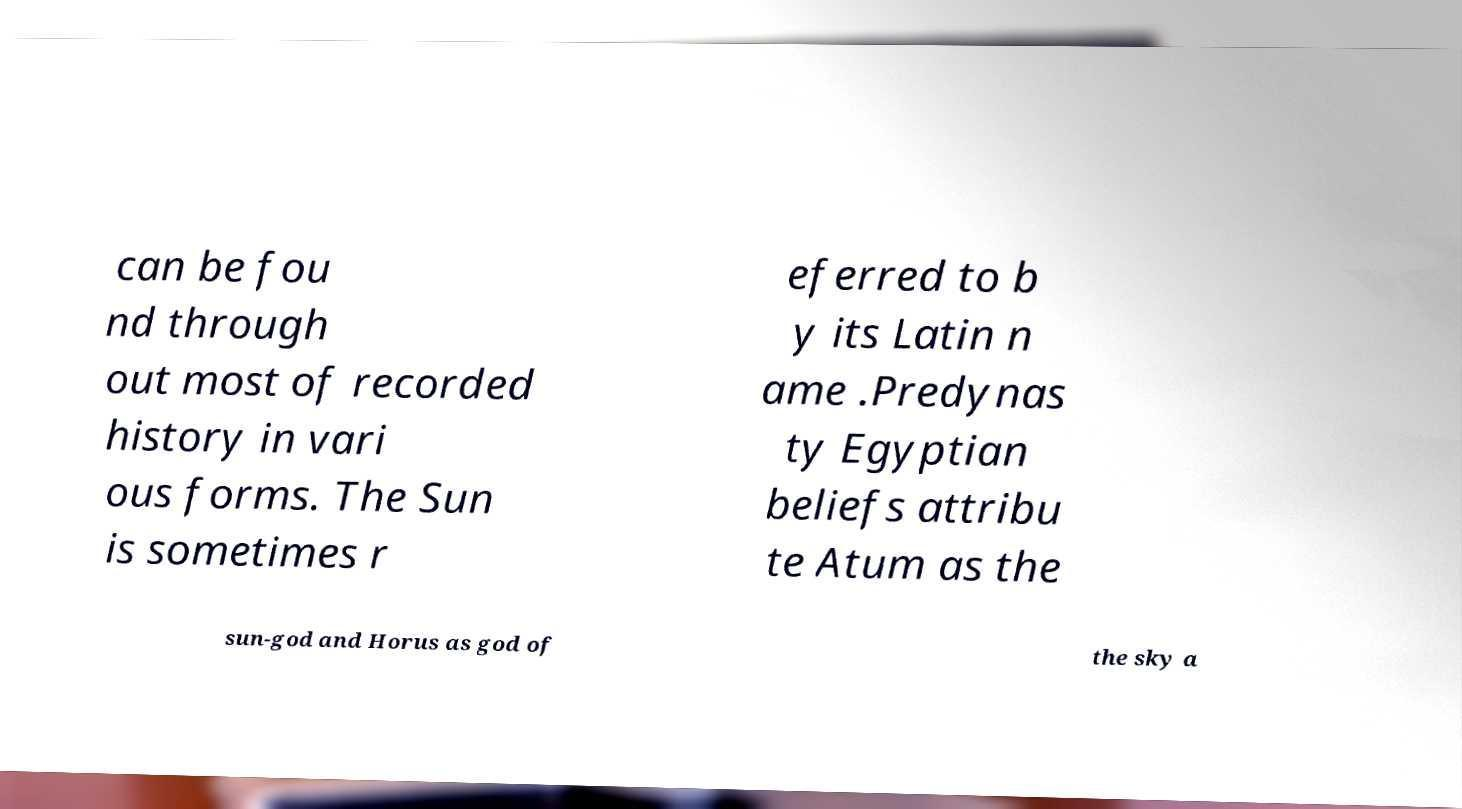There's text embedded in this image that I need extracted. Can you transcribe it verbatim? can be fou nd through out most of recorded history in vari ous forms. The Sun is sometimes r eferred to b y its Latin n ame .Predynas ty Egyptian beliefs attribu te Atum as the sun-god and Horus as god of the sky a 